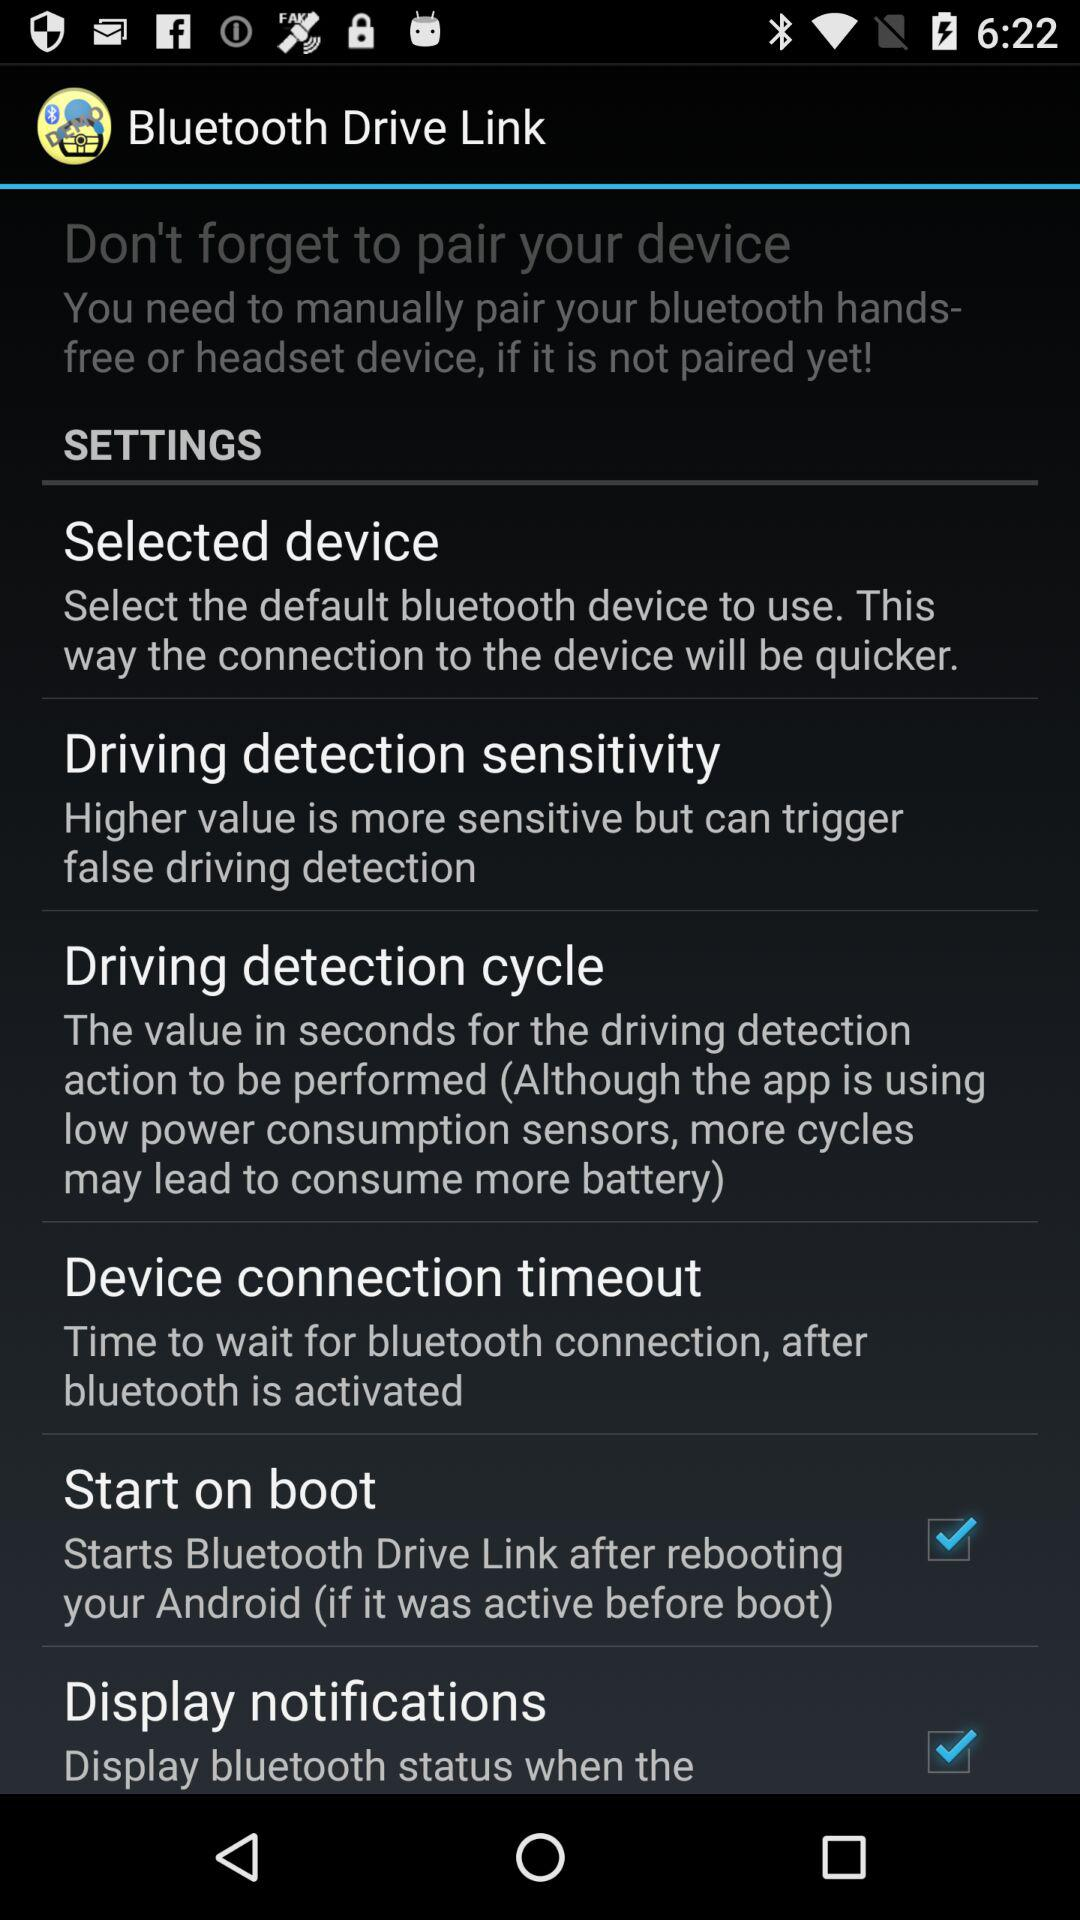What is the description of "Driving detection sensitivity"? The description is "Higher value is more sensitive but can trigger false driving detection". 